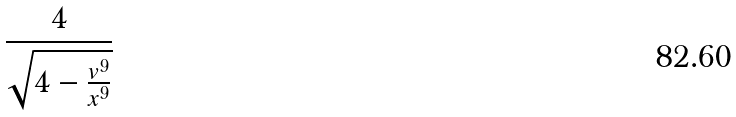<formula> <loc_0><loc_0><loc_500><loc_500>\frac { 4 } { \sqrt { 4 - \frac { v ^ { 9 } } { x ^ { 9 } } } }</formula> 